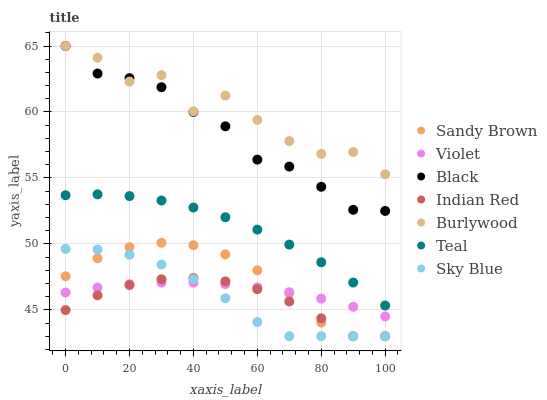Does Indian Red have the minimum area under the curve?
Answer yes or no. Yes. Does Burlywood have the maximum area under the curve?
Answer yes or no. Yes. Does Black have the minimum area under the curve?
Answer yes or no. No. Does Black have the maximum area under the curve?
Answer yes or no. No. Is Violet the smoothest?
Answer yes or no. Yes. Is Burlywood the roughest?
Answer yes or no. Yes. Is Black the smoothest?
Answer yes or no. No. Is Black the roughest?
Answer yes or no. No. Does Indian Red have the lowest value?
Answer yes or no. Yes. Does Black have the lowest value?
Answer yes or no. No. Does Black have the highest value?
Answer yes or no. Yes. Does Teal have the highest value?
Answer yes or no. No. Is Violet less than Teal?
Answer yes or no. Yes. Is Black greater than Violet?
Answer yes or no. Yes. Does Violet intersect Sandy Brown?
Answer yes or no. Yes. Is Violet less than Sandy Brown?
Answer yes or no. No. Is Violet greater than Sandy Brown?
Answer yes or no. No. Does Violet intersect Teal?
Answer yes or no. No. 